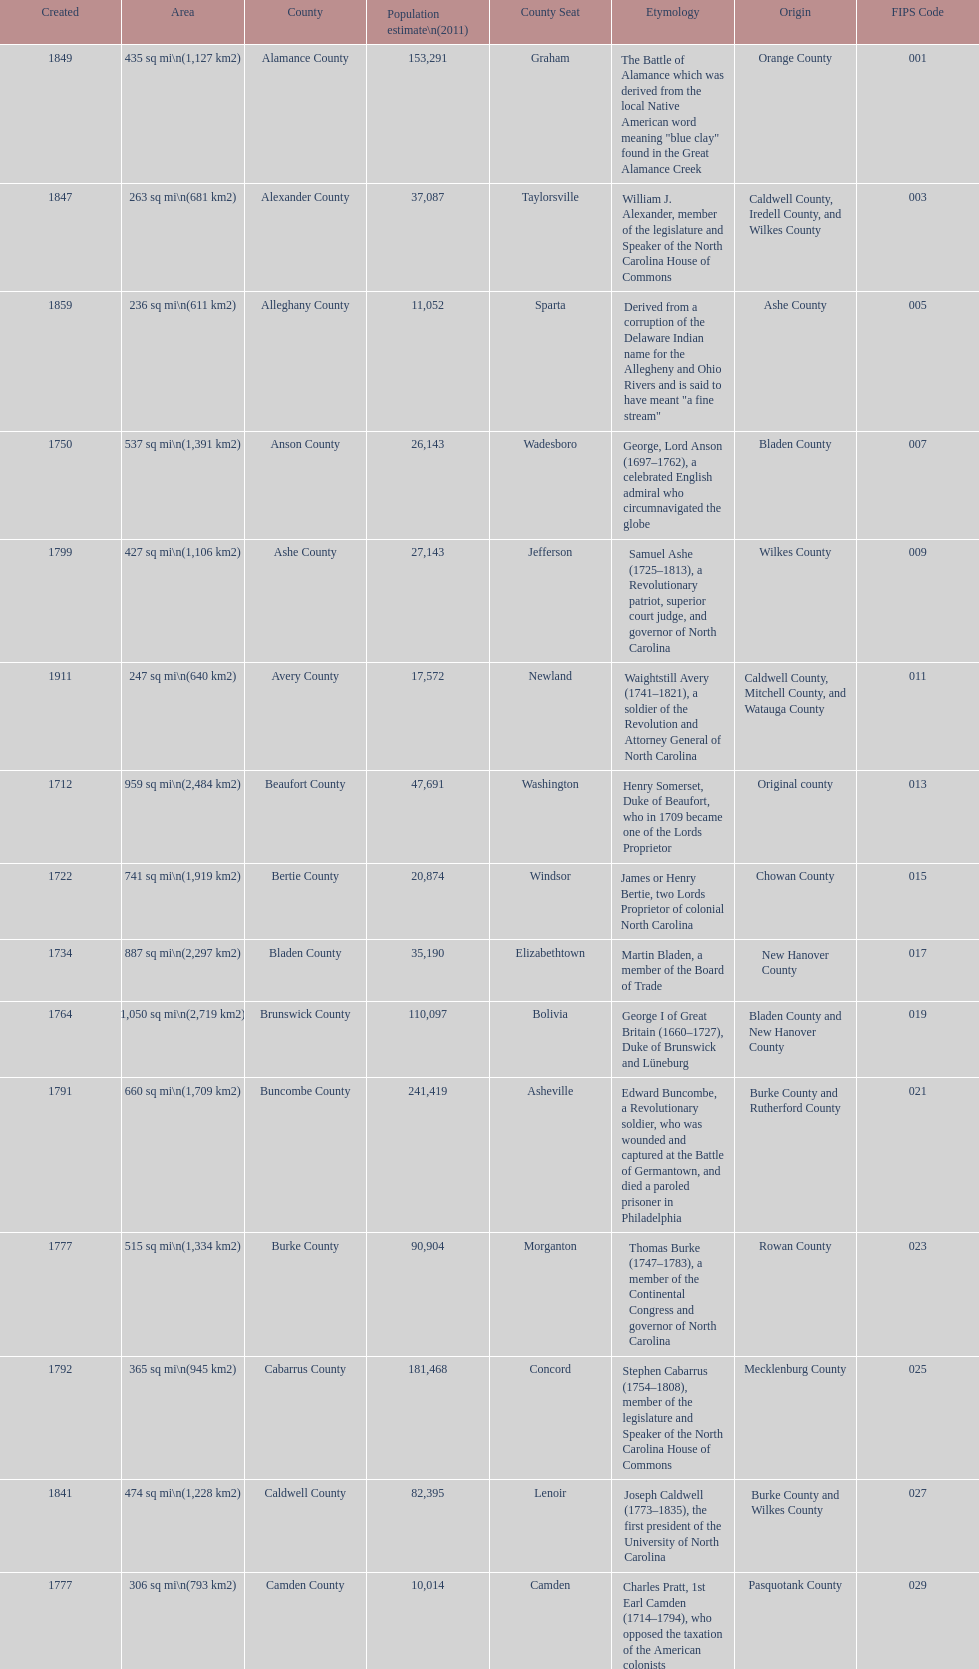Other than mecklenburg which county has the largest population? Wake County. 